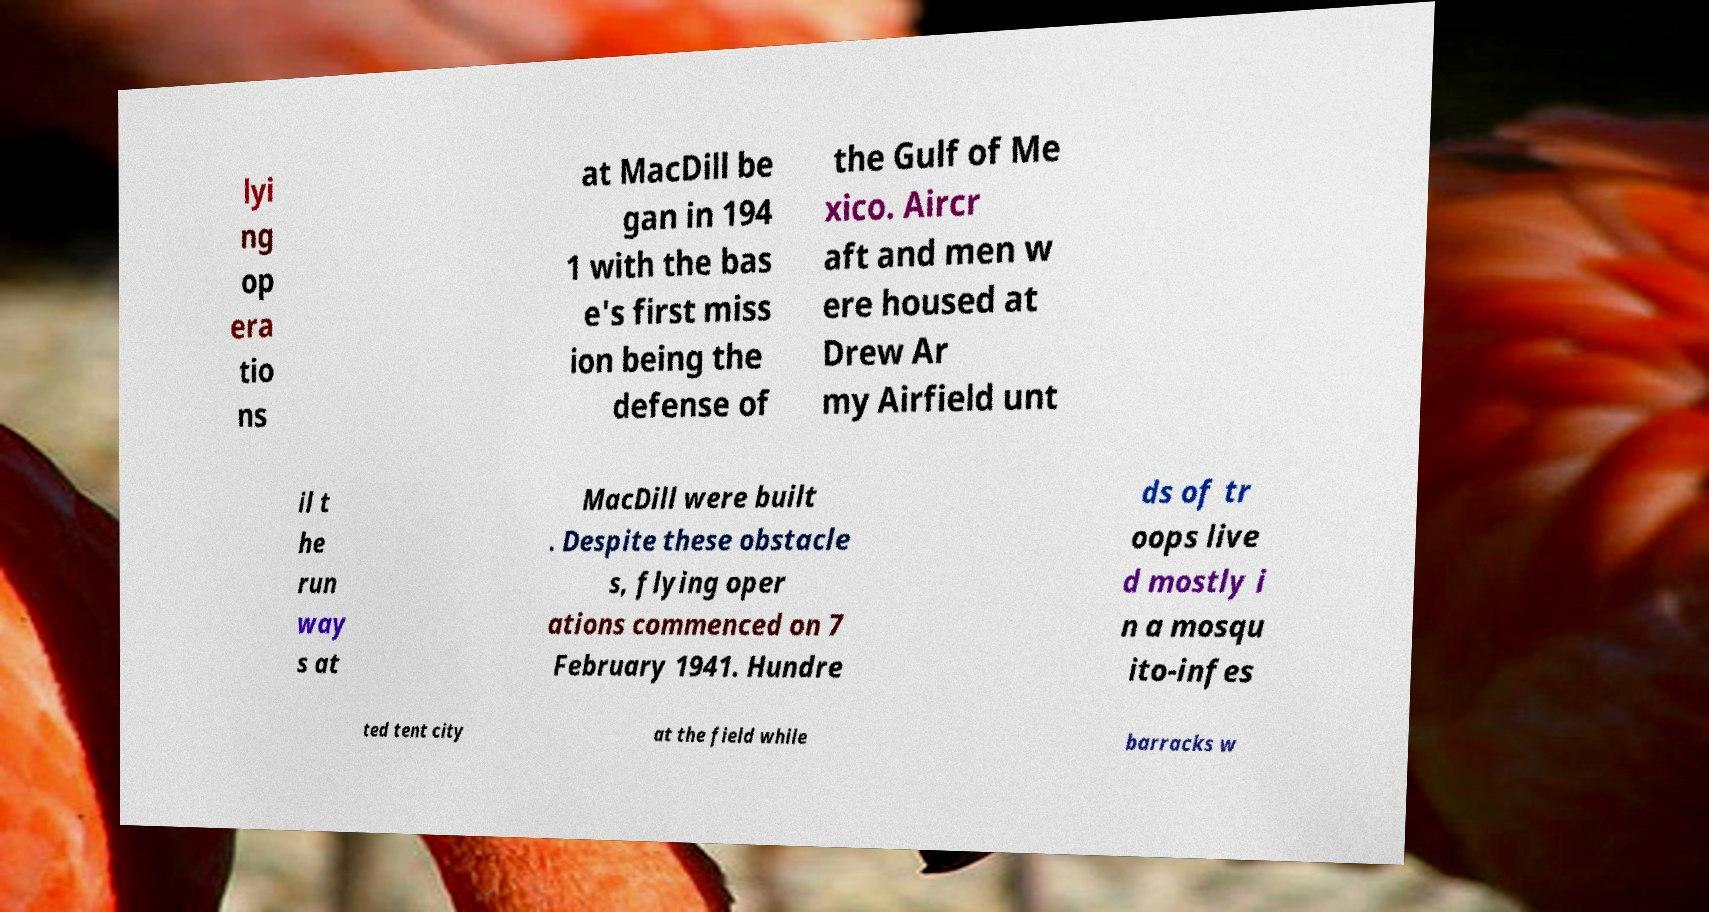Could you extract and type out the text from this image? lyi ng op era tio ns at MacDill be gan in 194 1 with the bas e's first miss ion being the defense of the Gulf of Me xico. Aircr aft and men w ere housed at Drew Ar my Airfield unt il t he run way s at MacDill were built . Despite these obstacle s, flying oper ations commenced on 7 February 1941. Hundre ds of tr oops live d mostly i n a mosqu ito-infes ted tent city at the field while barracks w 